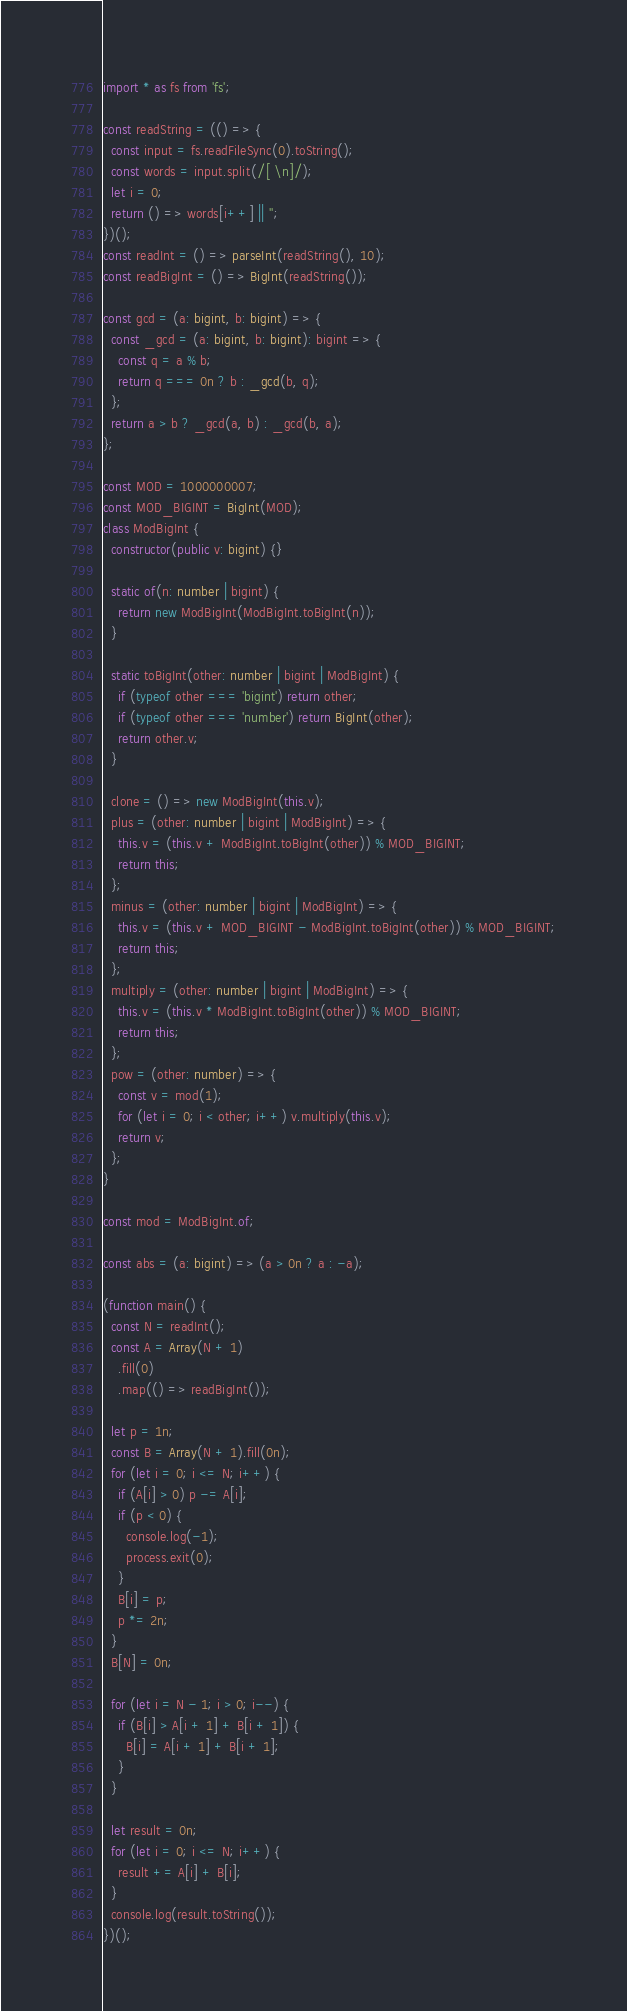Convert code to text. <code><loc_0><loc_0><loc_500><loc_500><_TypeScript_>import * as fs from 'fs';

const readString = (() => {
  const input = fs.readFileSync(0).toString();
  const words = input.split(/[ \n]/);
  let i = 0;
  return () => words[i++] || '';
})();
const readInt = () => parseInt(readString(), 10);
const readBigInt = () => BigInt(readString());

const gcd = (a: bigint, b: bigint) => {
  const _gcd = (a: bigint, b: bigint): bigint => {
    const q = a % b;
    return q === 0n ? b : _gcd(b, q);
  };
  return a > b ? _gcd(a, b) : _gcd(b, a);
};

const MOD = 1000000007;
const MOD_BIGINT = BigInt(MOD);
class ModBigInt {
  constructor(public v: bigint) {}

  static of(n: number | bigint) {
    return new ModBigInt(ModBigInt.toBigInt(n));
  }

  static toBigInt(other: number | bigint | ModBigInt) {
    if (typeof other === 'bigint') return other;
    if (typeof other === 'number') return BigInt(other);
    return other.v;
  }

  clone = () => new ModBigInt(this.v);
  plus = (other: number | bigint | ModBigInt) => {
    this.v = (this.v + ModBigInt.toBigInt(other)) % MOD_BIGINT;
    return this;
  };
  minus = (other: number | bigint | ModBigInt) => {
    this.v = (this.v + MOD_BIGINT - ModBigInt.toBigInt(other)) % MOD_BIGINT;
    return this;
  };
  multiply = (other: number | bigint | ModBigInt) => {
    this.v = (this.v * ModBigInt.toBigInt(other)) % MOD_BIGINT;
    return this;
  };
  pow = (other: number) => {
    const v = mod(1);
    for (let i = 0; i < other; i++) v.multiply(this.v);
    return v;
  };
}

const mod = ModBigInt.of;

const abs = (a: bigint) => (a > 0n ? a : -a);

(function main() {
  const N = readInt();
  const A = Array(N + 1)
    .fill(0)
    .map(() => readBigInt());

  let p = 1n;
  const B = Array(N + 1).fill(0n);
  for (let i = 0; i <= N; i++) {
    if (A[i] > 0) p -= A[i];
    if (p < 0) {
      console.log(-1);
      process.exit(0);
    }
    B[i] = p;
    p *= 2n;
  }
  B[N] = 0n;

  for (let i = N - 1; i > 0; i--) {
    if (B[i] > A[i + 1] + B[i + 1]) {
      B[i] = A[i + 1] + B[i + 1];
    }
  }

  let result = 0n;
  for (let i = 0; i <= N; i++) {
    result += A[i] + B[i];
  }
  console.log(result.toString());
})();
</code> 